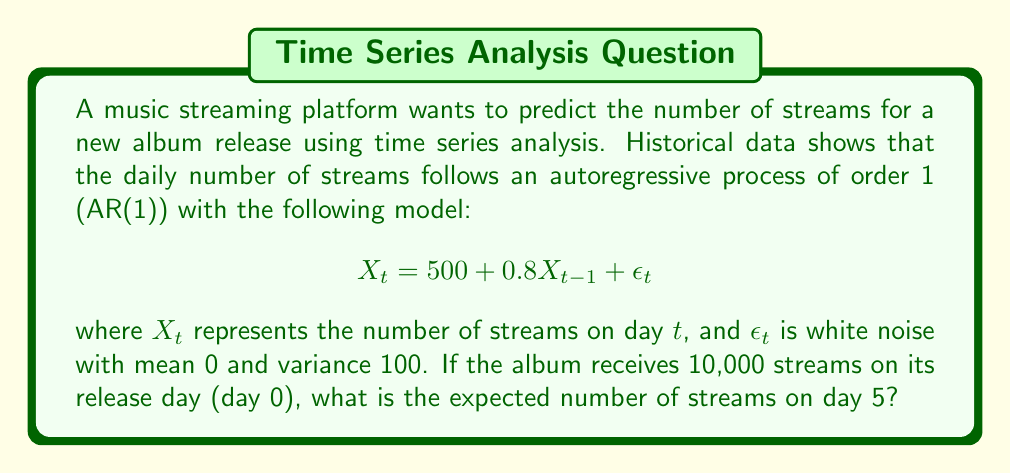Help me with this question. To solve this problem, we'll use the properties of AR(1) processes and iterate the model for 5 days:

1) First, recall that for an AR(1) process $X_t = c + \phi X_{t-1} + \epsilon_t$, the expected value at time $t$ is given by:

   $$E[X_t] = \frac{c}{1-\phi} + \phi^t (X_0 - \frac{c}{1-\phi})$$

   where $c$ is the constant term, $\phi$ is the autoregressive coefficient, and $X_0$ is the initial value.

2) In our case, $c = 500$, $\phi = 0.8$, and $X_0 = 10,000$.

3) Let's calculate $\frac{c}{1-\phi}$:

   $$\frac{c}{1-\phi} = \frac{500}{1-0.8} = \frac{500}{0.2} = 2,500$$

4) Now, we can plug these values into the formula:

   $$E[X_5] = 2,500 + 0.8^5 (10,000 - 2,500)$$

5) Calculate $0.8^5$:

   $$0.8^5 = 0.32768$$

6) Substitute this value:

   $$E[X_5] = 2,500 + 0.32768 (7,500)$$

7) Simplify:

   $$E[X_5] = 2,500 + 2,457.6 = 4,957.6$$

Therefore, the expected number of streams on day 5 is approximately 4,958 (rounded to the nearest integer).
Answer: 4,958 streams 